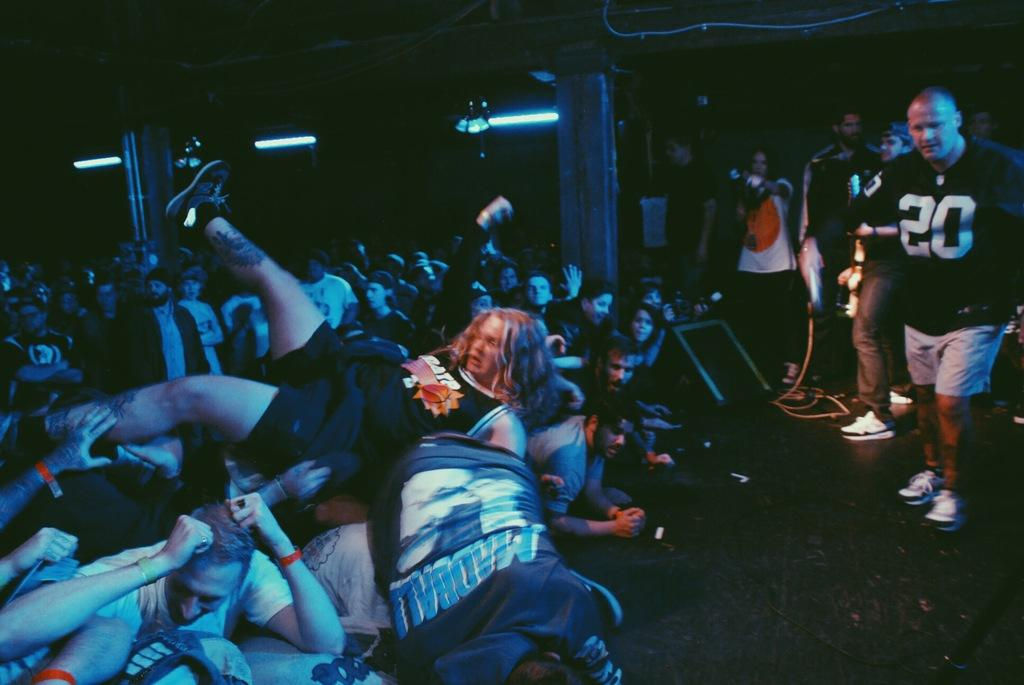Provide a one-sentence caption for the provided image. The man in the black jersey has the number 20 on the front. 